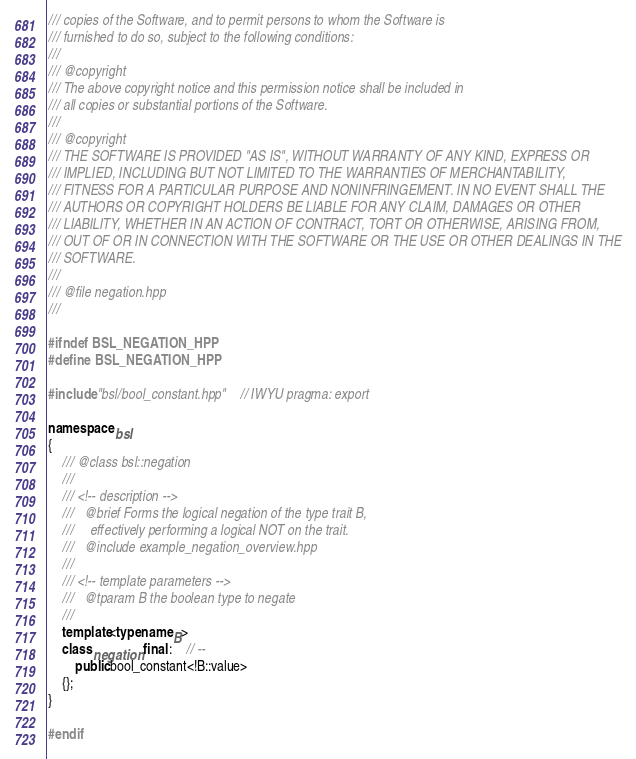Convert code to text. <code><loc_0><loc_0><loc_500><loc_500><_C++_>/// copies of the Software, and to permit persons to whom the Software is
/// furnished to do so, subject to the following conditions:
///
/// @copyright
/// The above copyright notice and this permission notice shall be included in
/// all copies or substantial portions of the Software.
///
/// @copyright
/// THE SOFTWARE IS PROVIDED "AS IS", WITHOUT WARRANTY OF ANY KIND, EXPRESS OR
/// IMPLIED, INCLUDING BUT NOT LIMITED TO THE WARRANTIES OF MERCHANTABILITY,
/// FITNESS FOR A PARTICULAR PURPOSE AND NONINFRINGEMENT. IN NO EVENT SHALL THE
/// AUTHORS OR COPYRIGHT HOLDERS BE LIABLE FOR ANY CLAIM, DAMAGES OR OTHER
/// LIABILITY, WHETHER IN AN ACTION OF CONTRACT, TORT OR OTHERWISE, ARISING FROM,
/// OUT OF OR IN CONNECTION WITH THE SOFTWARE OR THE USE OR OTHER DEALINGS IN THE
/// SOFTWARE.
///
/// @file negation.hpp
///

#ifndef BSL_NEGATION_HPP
#define BSL_NEGATION_HPP

#include "bsl/bool_constant.hpp"    // IWYU pragma: export

namespace bsl
{
    /// @class bsl::negation
    ///
    /// <!-- description -->
    ///   @brief Forms the logical negation of the type trait B,
    ///     effectively performing a logical NOT on the trait.
    ///   @include example_negation_overview.hpp
    ///
    /// <!-- template parameters -->
    ///   @tparam B the boolean type to negate
    ///
    template<typename B>
    class negation final :    // --
        public bool_constant<!B::value>
    {};
}

#endif
</code> 